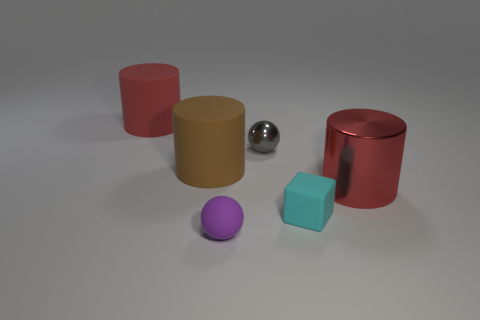Add 3 brown cylinders. How many objects exist? 9 Subtract all balls. How many objects are left? 4 Subtract 0 cyan spheres. How many objects are left? 6 Subtract all purple balls. Subtract all tiny purple rubber objects. How many objects are left? 4 Add 2 large brown matte cylinders. How many large brown matte cylinders are left? 3 Add 2 large red rubber cylinders. How many large red rubber cylinders exist? 3 